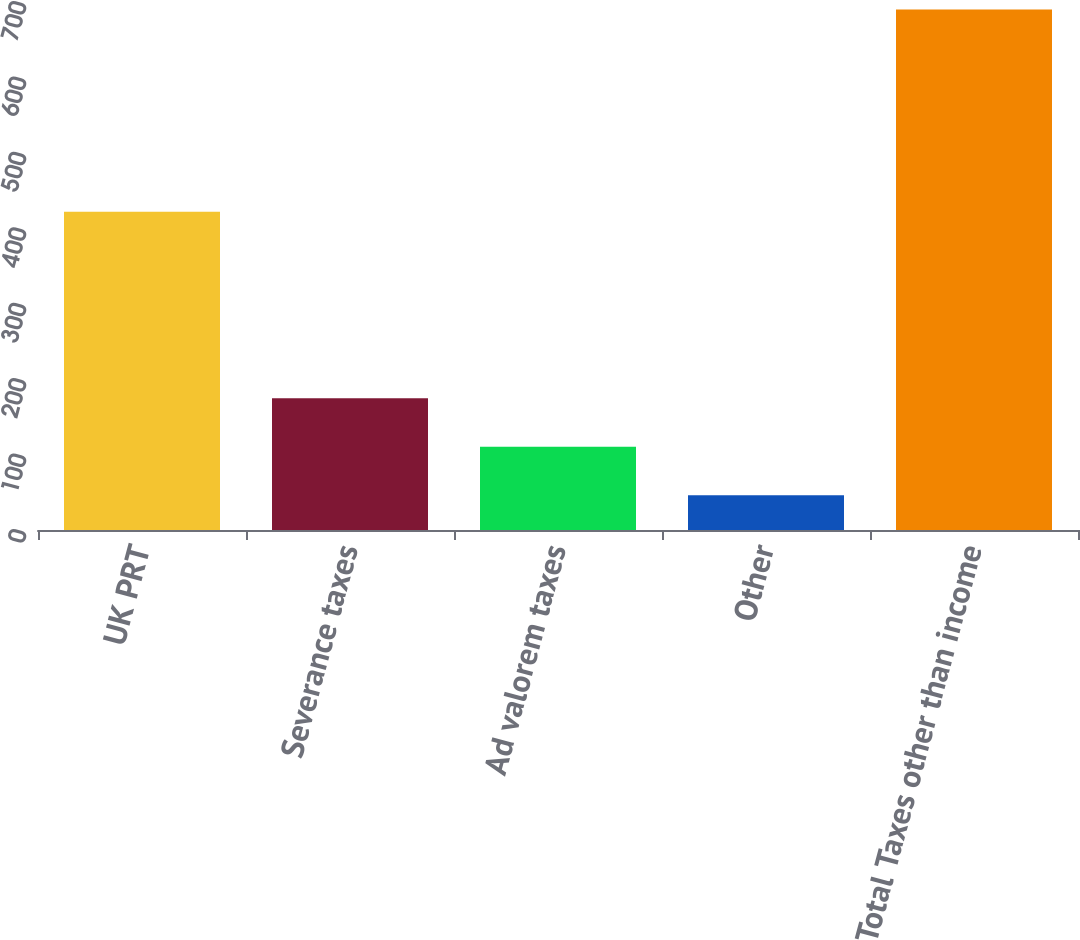Convert chart. <chart><loc_0><loc_0><loc_500><loc_500><bar_chart><fcel>UK PRT<fcel>Severance taxes<fcel>Ad valorem taxes<fcel>Other<fcel>Total Taxes other than income<nl><fcel>422<fcel>174.8<fcel>110.4<fcel>46<fcel>690<nl></chart> 